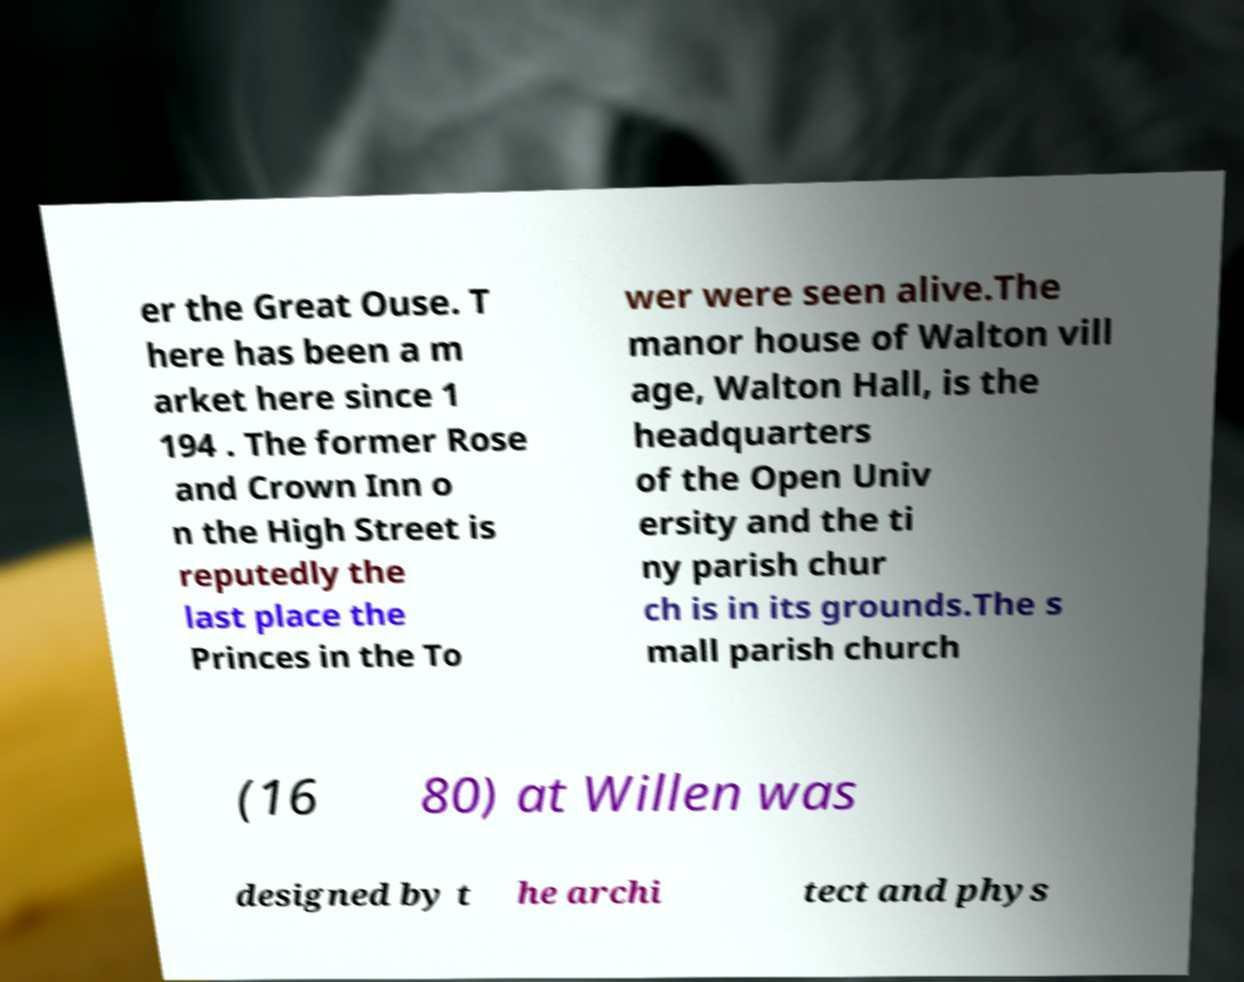Please identify and transcribe the text found in this image. er the Great Ouse. T here has been a m arket here since 1 194 . The former Rose and Crown Inn o n the High Street is reputedly the last place the Princes in the To wer were seen alive.The manor house of Walton vill age, Walton Hall, is the headquarters of the Open Univ ersity and the ti ny parish chur ch is in its grounds.The s mall parish church (16 80) at Willen was designed by t he archi tect and phys 